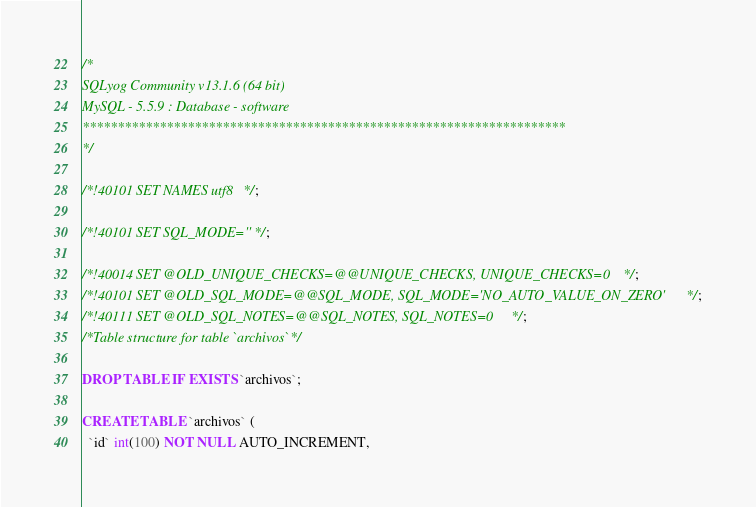<code> <loc_0><loc_0><loc_500><loc_500><_SQL_>/*
SQLyog Community v13.1.6 (64 bit)
MySQL - 5.5.9 : Database - software
*********************************************************************
*/

/*!40101 SET NAMES utf8 */;

/*!40101 SET SQL_MODE=''*/;

/*!40014 SET @OLD_UNIQUE_CHECKS=@@UNIQUE_CHECKS, UNIQUE_CHECKS=0 */;
/*!40101 SET @OLD_SQL_MODE=@@SQL_MODE, SQL_MODE='NO_AUTO_VALUE_ON_ZERO' */;
/*!40111 SET @OLD_SQL_NOTES=@@SQL_NOTES, SQL_NOTES=0 */;
/*Table structure for table `archivos` */

DROP TABLE IF EXISTS `archivos`;

CREATE TABLE `archivos` (
  `id` int(100) NOT NULL AUTO_INCREMENT,</code> 